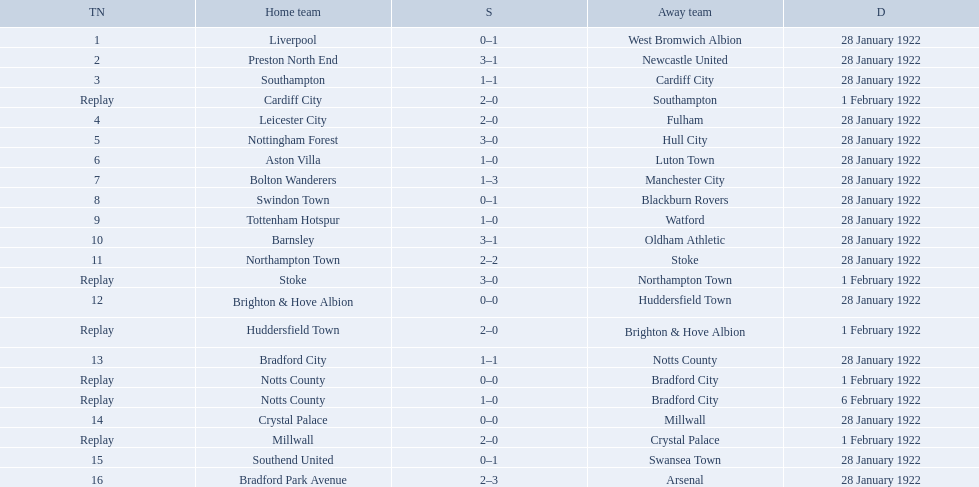What was the score in the aston villa game? 1–0. Which other team had an identical score? Tottenham Hotspur. What are all of the home teams? Liverpool, Preston North End, Southampton, Cardiff City, Leicester City, Nottingham Forest, Aston Villa, Bolton Wanderers, Swindon Town, Tottenham Hotspur, Barnsley, Northampton Town, Stoke, Brighton & Hove Albion, Huddersfield Town, Bradford City, Notts County, Notts County, Crystal Palace, Millwall, Southend United, Bradford Park Avenue. What were the scores? 0–1, 3–1, 1–1, 2–0, 2–0, 3–0, 1–0, 1–3, 0–1, 1–0, 3–1, 2–2, 3–0, 0–0, 2–0, 1–1, 0–0, 1–0, 0–0, 2–0, 0–1, 2–3. On which dates did they play? 28 January 1922, 28 January 1922, 28 January 1922, 1 February 1922, 28 January 1922, 28 January 1922, 28 January 1922, 28 January 1922, 28 January 1922, 28 January 1922, 28 January 1922, 28 January 1922, 1 February 1922, 28 January 1922, 1 February 1922, 28 January 1922, 1 February 1922, 6 February 1922, 28 January 1922, 1 February 1922, 28 January 1922, 28 January 1922. Which teams played on 28 january 1922? Liverpool, Preston North End, Southampton, Leicester City, Nottingham Forest, Aston Villa, Bolton Wanderers, Swindon Town, Tottenham Hotspur, Barnsley, Northampton Town, Brighton & Hove Albion, Bradford City, Crystal Palace, Southend United, Bradford Park Avenue. Of those, which scored the same as aston villa? Tottenham Hotspur. 